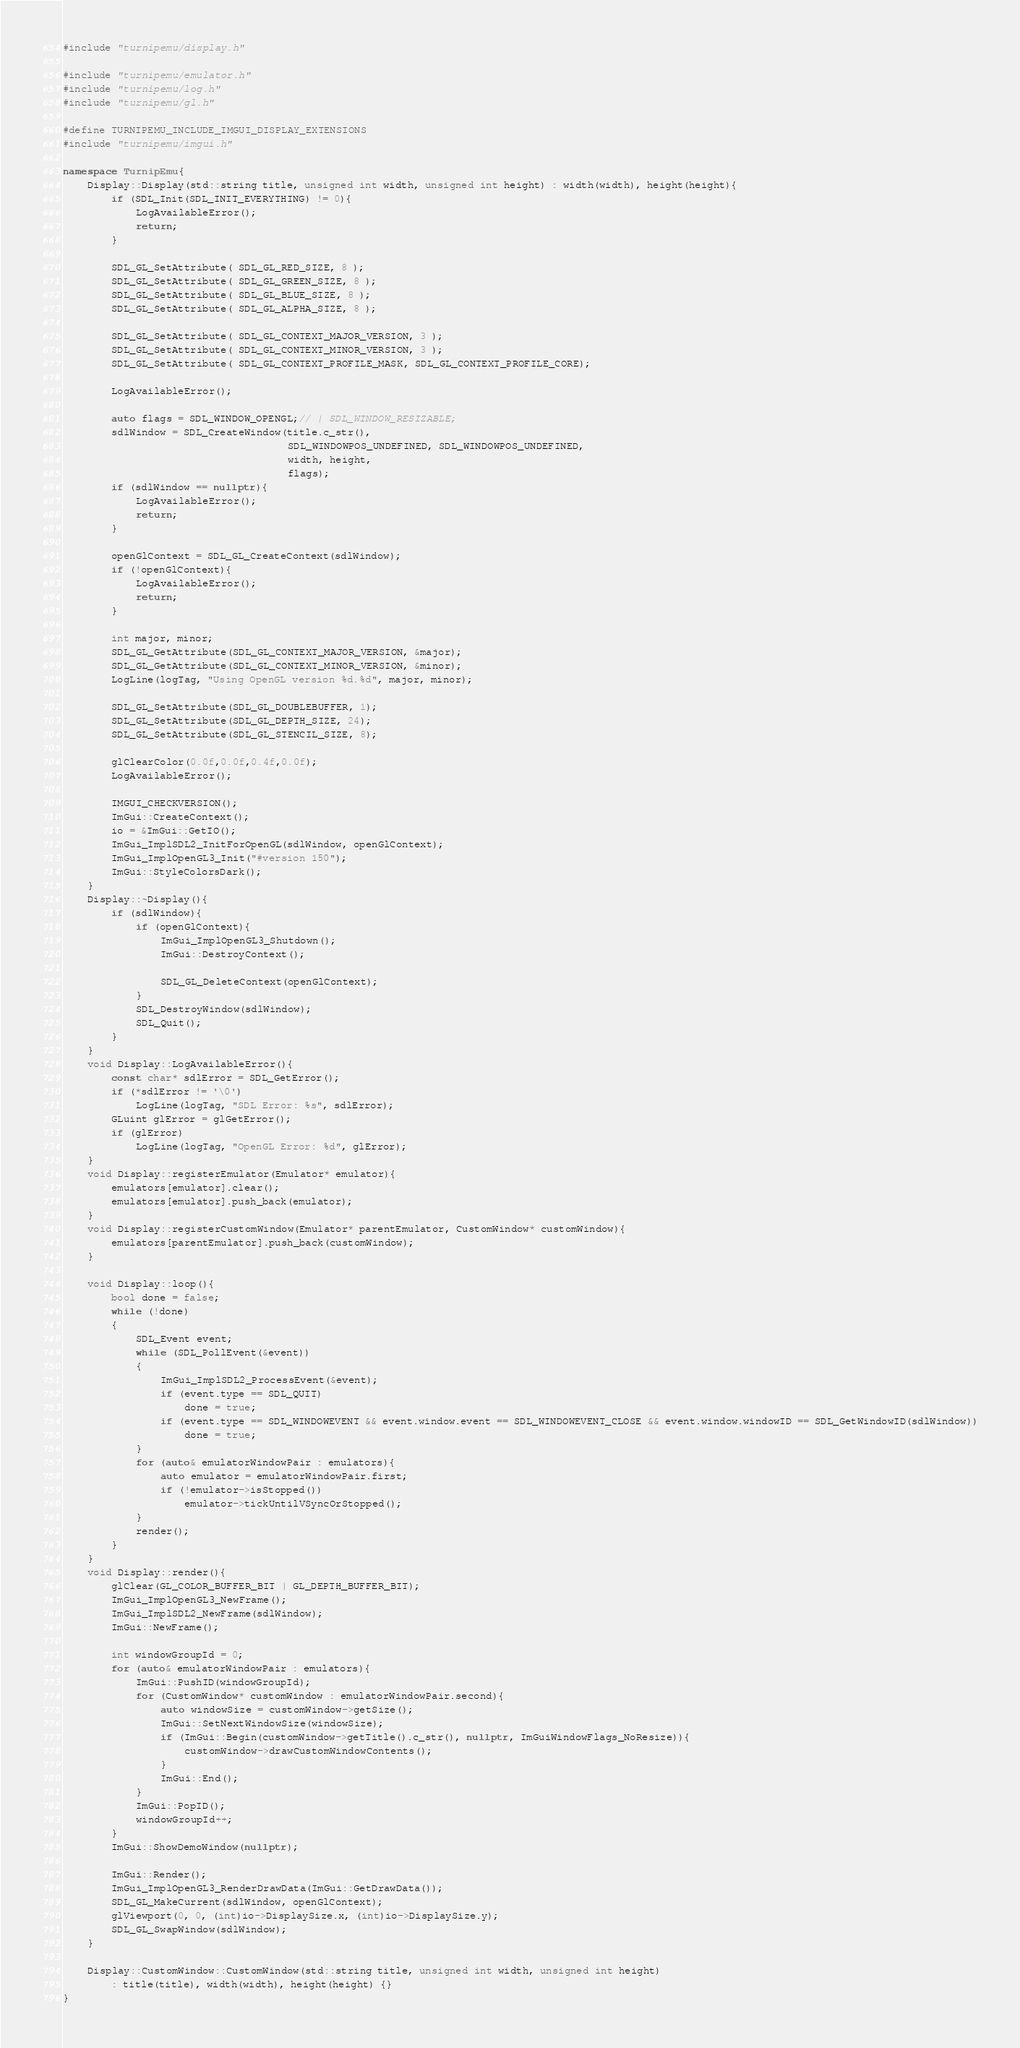Convert code to text. <code><loc_0><loc_0><loc_500><loc_500><_C++_>#include "turnipemu/display.h"

#include "turnipemu/emulator.h"
#include "turnipemu/log.h"
#include "turnipemu/gl.h"

#define TURNIPEMU_INCLUDE_IMGUI_DISPLAY_EXTENSIONS
#include "turnipemu/imgui.h"

namespace TurnipEmu{
	Display::Display(std::string title, unsigned int width, unsigned int height) : width(width), height(height){
		if (SDL_Init(SDL_INIT_EVERYTHING) != 0){
			LogAvailableError();
			return;
		}
    
		SDL_GL_SetAttribute( SDL_GL_RED_SIZE, 8 );
		SDL_GL_SetAttribute( SDL_GL_GREEN_SIZE, 8 );
		SDL_GL_SetAttribute( SDL_GL_BLUE_SIZE, 8 );
		SDL_GL_SetAttribute( SDL_GL_ALPHA_SIZE, 8 );
    
		SDL_GL_SetAttribute( SDL_GL_CONTEXT_MAJOR_VERSION, 3 );
		SDL_GL_SetAttribute( SDL_GL_CONTEXT_MINOR_VERSION, 3 );
		SDL_GL_SetAttribute( SDL_GL_CONTEXT_PROFILE_MASK, SDL_GL_CONTEXT_PROFILE_CORE);

		LogAvailableError();
    
		auto flags = SDL_WINDOW_OPENGL;// | SDL_WINDOW_RESIZABLE;
		sdlWindow = SDL_CreateWindow(title.c_str(),
									 SDL_WINDOWPOS_UNDEFINED, SDL_WINDOWPOS_UNDEFINED,
									 width, height,
									 flags);
		if (sdlWindow == nullptr){
			LogAvailableError();
			return;
		}

		openGlContext = SDL_GL_CreateContext(sdlWindow);
		if (!openGlContext){
			LogAvailableError();
			return;
		}
    
		int major, minor;
		SDL_GL_GetAttribute(SDL_GL_CONTEXT_MAJOR_VERSION, &major);
		SDL_GL_GetAttribute(SDL_GL_CONTEXT_MINOR_VERSION, &minor);
		LogLine(logTag, "Using OpenGL version %d.%d", major, minor);

		SDL_GL_SetAttribute(SDL_GL_DOUBLEBUFFER, 1);
		SDL_GL_SetAttribute(SDL_GL_DEPTH_SIZE, 24);
		SDL_GL_SetAttribute(SDL_GL_STENCIL_SIZE, 8);

		glClearColor(0.0f,0.0f,0.4f,0.0f);
		LogAvailableError();

		IMGUI_CHECKVERSION();
		ImGui::CreateContext();
		io = &ImGui::GetIO();
		ImGui_ImplSDL2_InitForOpenGL(sdlWindow, openGlContext);
		ImGui_ImplOpenGL3_Init("#version 150");
		ImGui::StyleColorsDark();
	}
	Display::~Display(){
		if (sdlWindow){
			if (openGlContext){
				ImGui_ImplOpenGL3_Shutdown();
				ImGui::DestroyContext();
				
				SDL_GL_DeleteContext(openGlContext);
			}
			SDL_DestroyWindow(sdlWindow);
			SDL_Quit();
		}
	}
	void Display::LogAvailableError(){
		const char* sdlError = SDL_GetError();
		if (*sdlError != '\0')
			LogLine(logTag, "SDL Error: %s", sdlError);
		GLuint glError = glGetError();
		if (glError)
			LogLine(logTag, "OpenGL Error: %d", glError);
	}
	void Display::registerEmulator(Emulator* emulator){
		emulators[emulator].clear();
		emulators[emulator].push_back(emulator);
	}
	void Display::registerCustomWindow(Emulator* parentEmulator, CustomWindow* customWindow){
		emulators[parentEmulator].push_back(customWindow);
	}

	void Display::loop(){
		bool done = false;
		while (!done)
		{
			SDL_Event event;
			while (SDL_PollEvent(&event))
			{
				ImGui_ImplSDL2_ProcessEvent(&event);
				if (event.type == SDL_QUIT)
					done = true;
				if (event.type == SDL_WINDOWEVENT && event.window.event == SDL_WINDOWEVENT_CLOSE && event.window.windowID == SDL_GetWindowID(sdlWindow))
					done = true;
			}
			for (auto& emulatorWindowPair : emulators){
				auto emulator = emulatorWindowPair.first;
				if (!emulator->isStopped())
					emulator->tickUntilVSyncOrStopped();
			}
			render();
		}
	}
	void Display::render(){
		glClear(GL_COLOR_BUFFER_BIT | GL_DEPTH_BUFFER_BIT);
		ImGui_ImplOpenGL3_NewFrame();
		ImGui_ImplSDL2_NewFrame(sdlWindow);
		ImGui::NewFrame();

		int windowGroupId = 0;
		for (auto& emulatorWindowPair : emulators){
			ImGui::PushID(windowGroupId);
			for (CustomWindow* customWindow : emulatorWindowPair.second){
				auto windowSize = customWindow->getSize();
				ImGui::SetNextWindowSize(windowSize);
				if (ImGui::Begin(customWindow->getTitle().c_str(), nullptr, ImGuiWindowFlags_NoResize)){
					customWindow->drawCustomWindowContents();
				}
				ImGui::End();
			}
			ImGui::PopID();
			windowGroupId++;
		}
		ImGui::ShowDemoWindow(nullptr);

		ImGui::Render();
		ImGui_ImplOpenGL3_RenderDrawData(ImGui::GetDrawData());
		SDL_GL_MakeCurrent(sdlWindow, openGlContext);
        glViewport(0, 0, (int)io->DisplaySize.x, (int)io->DisplaySize.y);
		SDL_GL_SwapWindow(sdlWindow);
	}

	Display::CustomWindow::CustomWindow(std::string title, unsigned int width, unsigned int height)
		: title(title), width(width), height(height) {}
}
</code> 